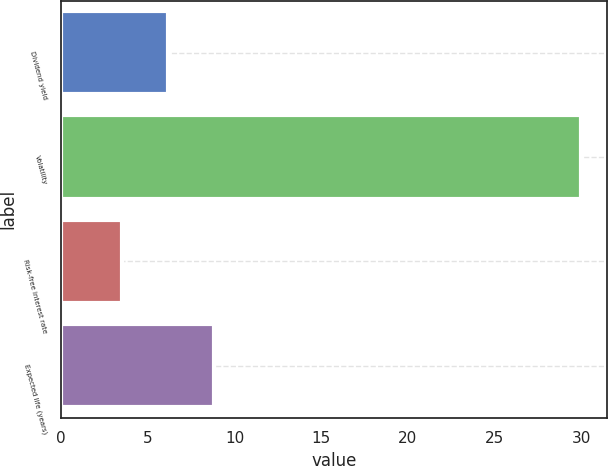Convert chart to OTSL. <chart><loc_0><loc_0><loc_500><loc_500><bar_chart><fcel>Dividend yield<fcel>Volatility<fcel>Risk-free interest rate<fcel>Expected life (years)<nl><fcel>6.15<fcel>30<fcel>3.5<fcel>8.8<nl></chart> 